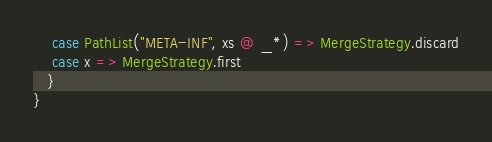<code> <loc_0><loc_0><loc_500><loc_500><_Scala_>    case PathList("META-INF", xs @ _*) => MergeStrategy.discard
    case x => MergeStrategy.first
   }
}</code> 